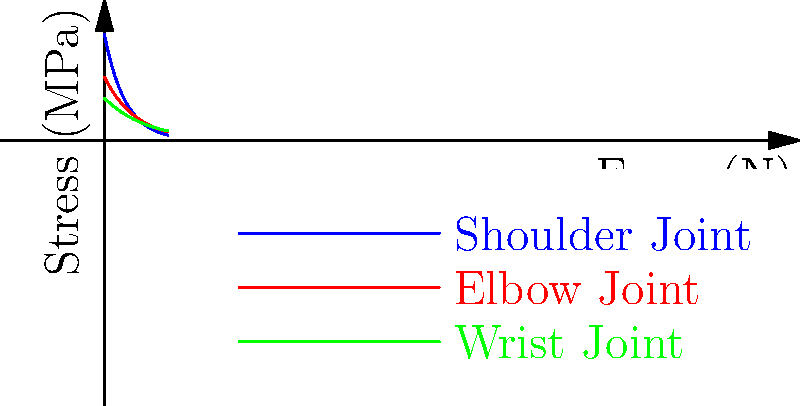In a futuristic exoskeleton designed for high-speed movement, the stress distribution across various joints is crucial for performance and safety. Analyzing the graph, which joint experiences the highest initial stress but also the most rapid stress reduction as force increases? How might this affect the design of the exoskeleton in the context of string theory's concept of extra dimensions? To answer this question, let's analyze the graph step-by-step:

1. The graph shows stress distribution curves for three joints: shoulder (blue), elbow (red), and wrist (green).

2. Initial stress levels (at force = 0):
   - Shoulder joint: ~50 MPa
   - Elbow joint: ~30 MPa
   - Wrist joint: ~20 MPa

3. Rate of stress reduction:
   - Shoulder joint: Steepest curve, indicating the fastest stress reduction
   - Elbow joint: Moderate curve
   - Wrist joint: Shallowest curve, indicating the slowest stress reduction

4. The shoulder joint clearly has both the highest initial stress and the steepest curve, indicating the most rapid stress reduction as force increases.

5. In the context of string theory's concept of extra dimensions:
   - String theory posits that our universe may have additional spatial dimensions beyond the three we observe.
   - These extra dimensions could potentially be utilized in the exoskeleton design to distribute stress more efficiently.
   - The rapid stress reduction in the shoulder joint could be explained by a design that leverages these extra dimensions to dissipate force quickly.
   - This could involve materials or structures that interact with these hypothetical extra dimensions, allowing for more efficient energy transfer and stress distribution.

6. Design implications:
   - The exoskeleton could incorporate advanced materials inspired by string theory concepts, such as "dimensional shunting" polymers that redirect stress through microscopic extra-dimensional pathways.
   - The shoulder joint's design might include more of these theoretical materials to handle its higher initial stress and facilitate rapid stress reduction.
   - This could result in a lighter, more efficient exoskeleton that performs exceptionally well during high-speed movements.
Answer: Shoulder joint; enables efficient stress distribution through extra-dimensional pathways. 